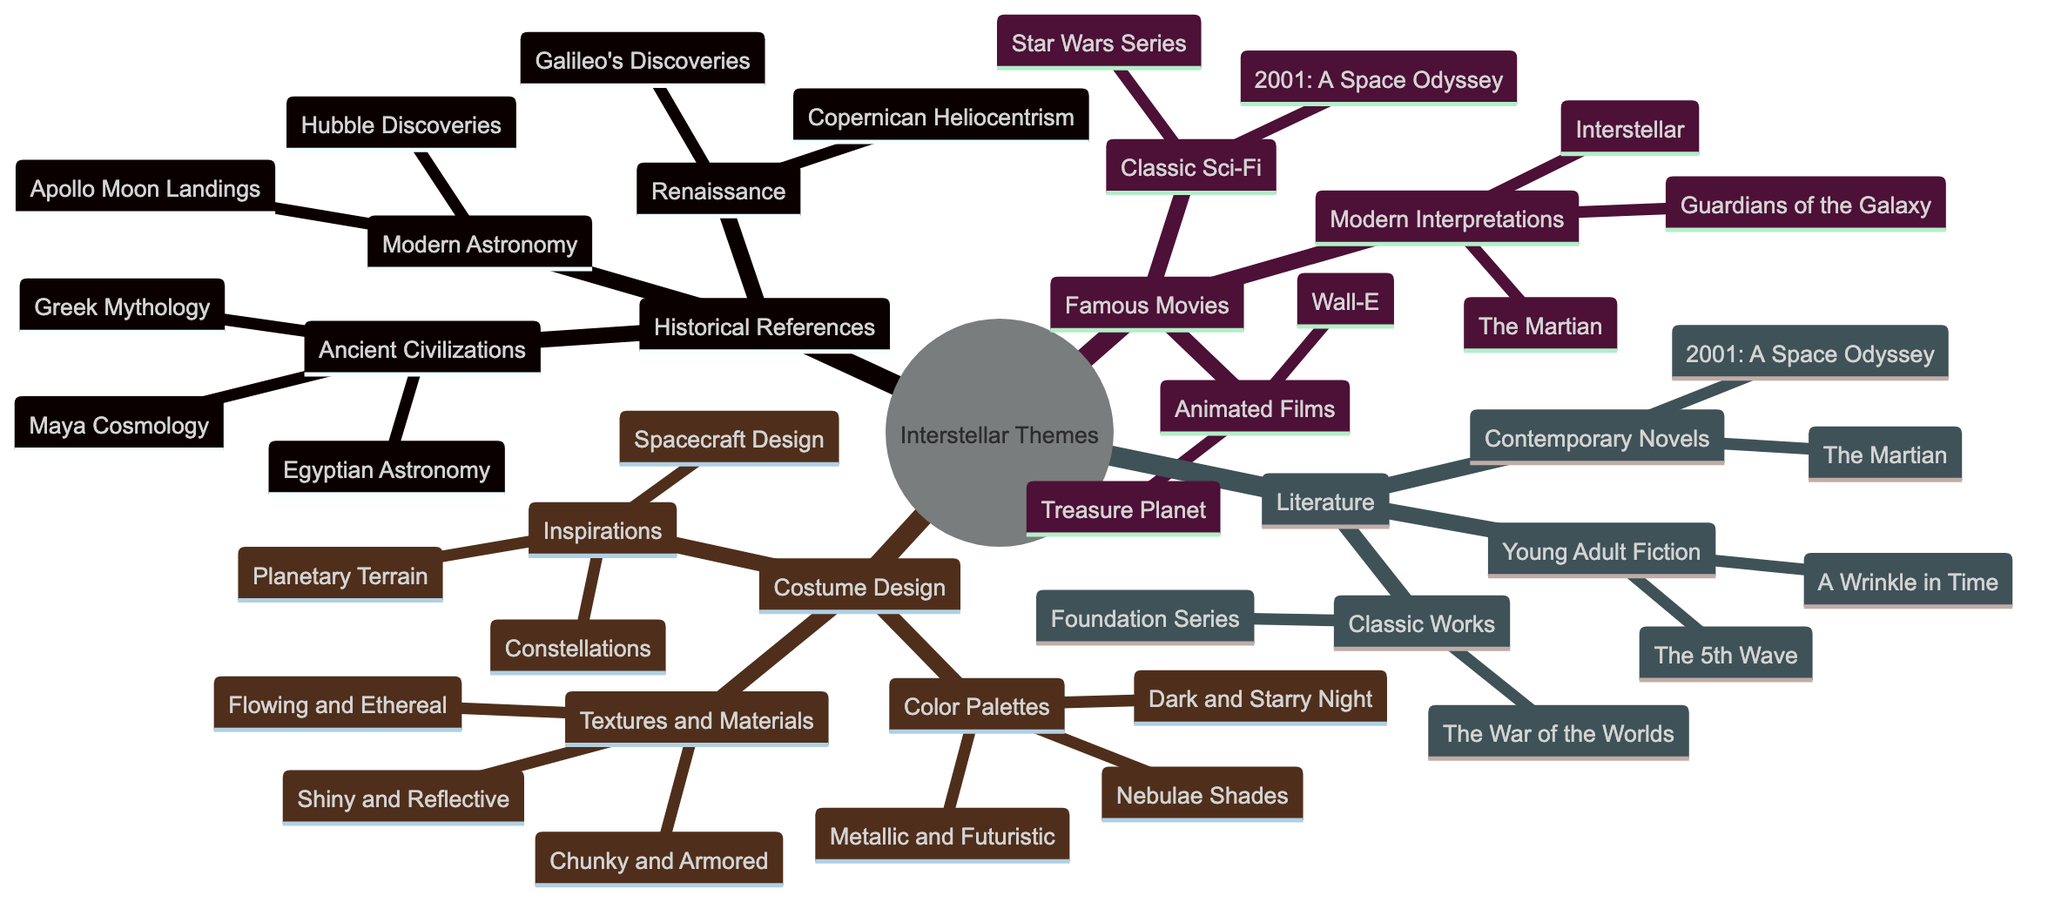What is the core theme of the diagram? The core theme is clearly stated at the root of the diagram as "Interstellar Themes in History and Popular Culture."
Answer: Interstellar Themes in History and Popular Culture How many sub-themes are under the "Famous Movies" category? There are three sub-categories listed under "Famous Movies": Classic Sci-Fi, Modern Interpretations, and Animated Films. Therefore, the total number is three.
Answer: 3 What celestial theme is associated with Ancient Civilizations? Under the "Historical References" section, Ancient Civilizations feature three themes, specifically mentioning Egyptian Astronomy, Maya Cosmology, and Greek Mythology.
Answer: Egyptian Astronomy Which classic literature work was published in 1898? The diagram lists "H.G. Wells' The War of the Worlds" under the "Classic Works" category in Literature, with a publication year of 1898.
Answer: The War of the Worlds What type of color palette represents nebulae in costume design? The "Color Palettes" section indicates that nebulae shades refer specifically to the colors inspired by nebulae, linking it to the theme of space and celestial designs.
Answer: Nebulae Shades How many total historical references are mentioned? Under "Historical References," there are sections for Ancient Civilizations (3), Renaissance (2), and Modern Astronomy (2), totaling 7 historical references when summed.
Answer: 7 What kind of textures are described as "Shiny and Reflective"? In the "Textures and Materials" section, "Shiny and Reflective" refers specifically to materials that are used for astronaut suits, highlighting their polished and modern appearance.
Answer: astronaut suits Which famous modern movie released in 2014 is mentioned? The diagram lists "Interstellar (2014)" under the "Modern Interpretations" in the "Famous Movies" category, denoting its relevance to interstellar themes.
Answer: Interstellar What are two inspirations in guiding costume design? The diagram identifies inspirations such as "Constellations and Astrological Symbols" and "Planetary Terrain and Atmospheres," highlighting the thematic elements designers can draw from.
Answer: Constellations and Astrological Symbols, Planetary Terrain and Atmospheres 